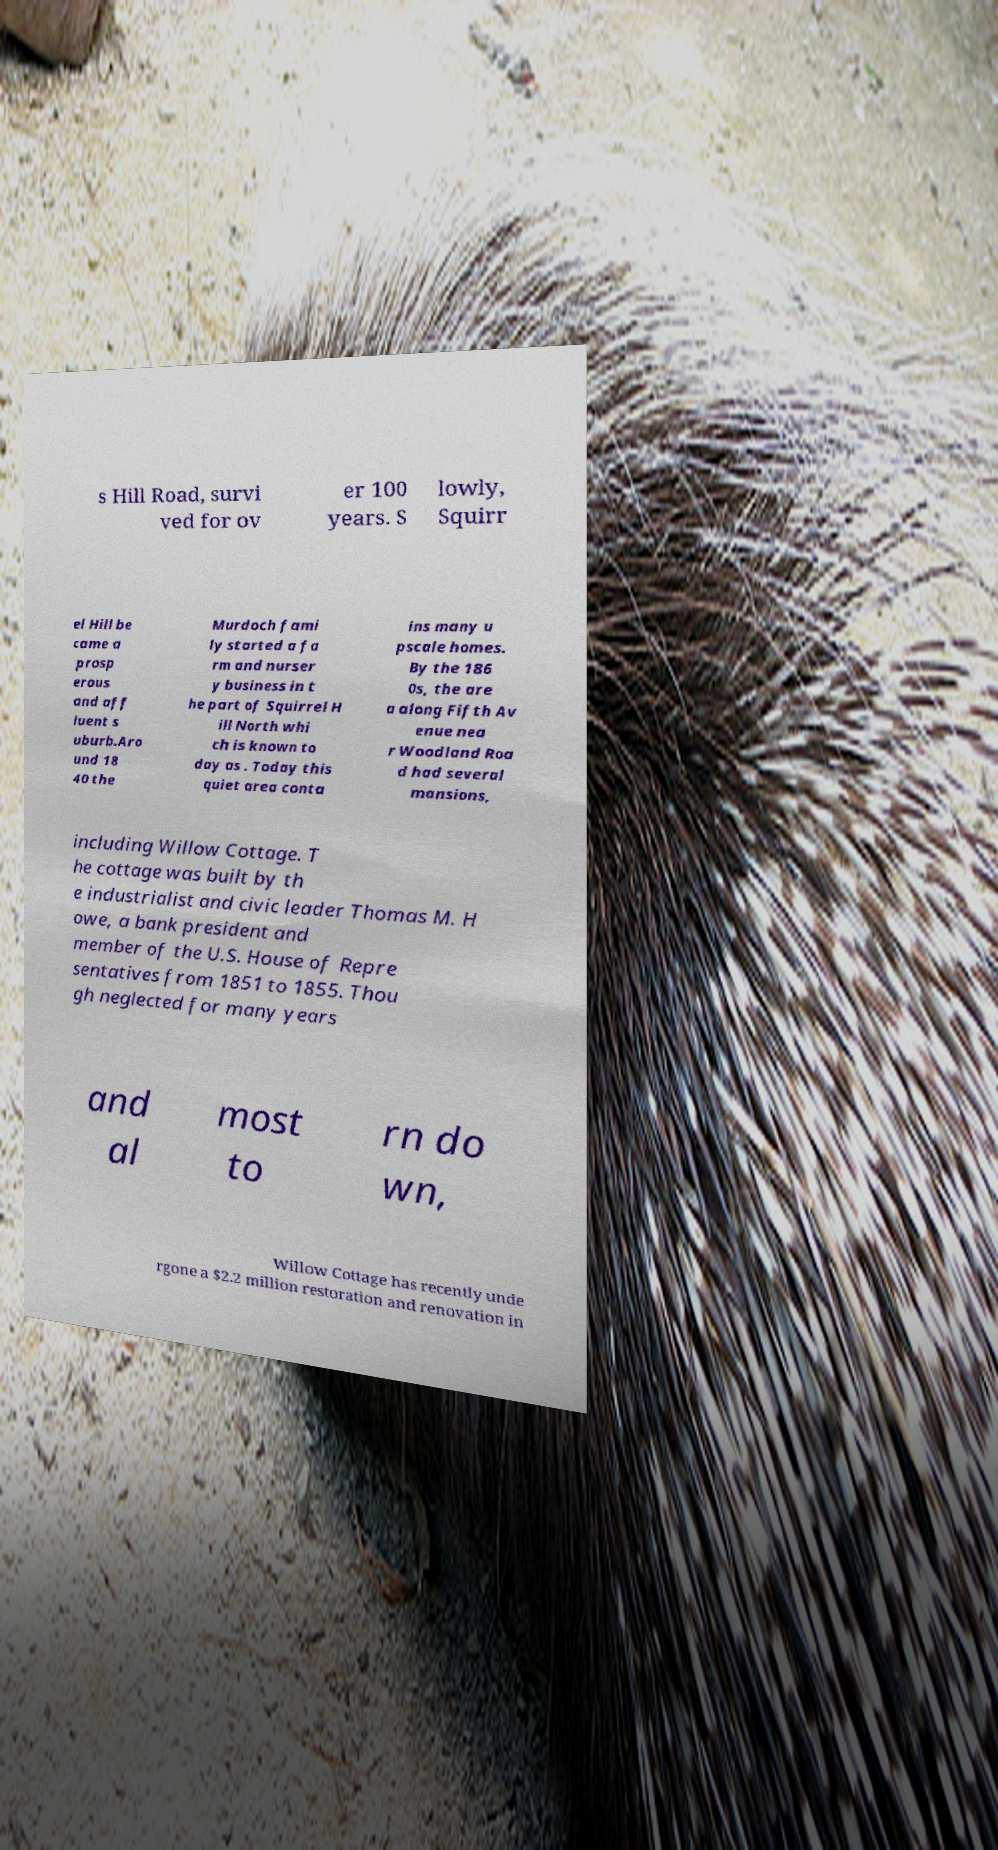Could you assist in decoding the text presented in this image and type it out clearly? s Hill Road, survi ved for ov er 100 years. S lowly, Squirr el Hill be came a prosp erous and aff luent s uburb.Aro und 18 40 the Murdoch fami ly started a fa rm and nurser y business in t he part of Squirrel H ill North whi ch is known to day as . Today this quiet area conta ins many u pscale homes. By the 186 0s, the are a along Fifth Av enue nea r Woodland Roa d had several mansions, including Willow Cottage. T he cottage was built by th e industrialist and civic leader Thomas M. H owe, a bank president and member of the U.S. House of Repre sentatives from 1851 to 1855. Thou gh neglected for many years and al most to rn do wn, Willow Cottage has recently unde rgone a $2.2 million restoration and renovation in 